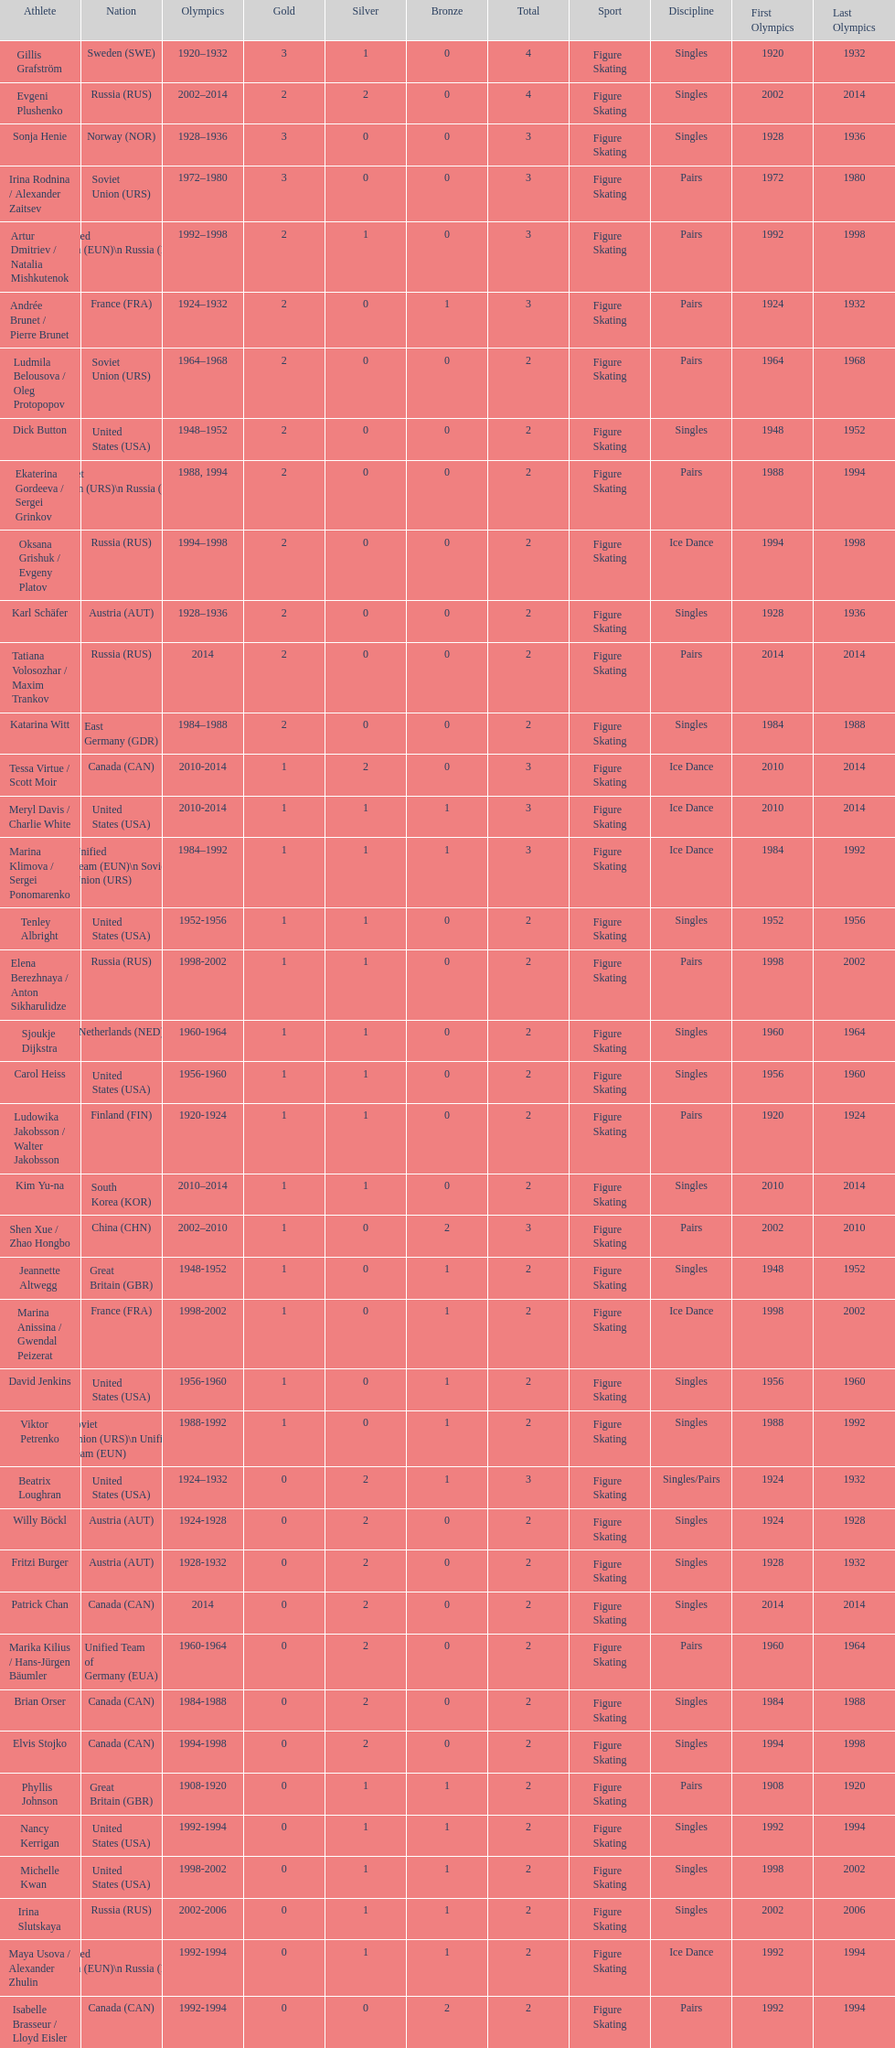What is the record for the most gold medals secured by a single competitor? 3. 